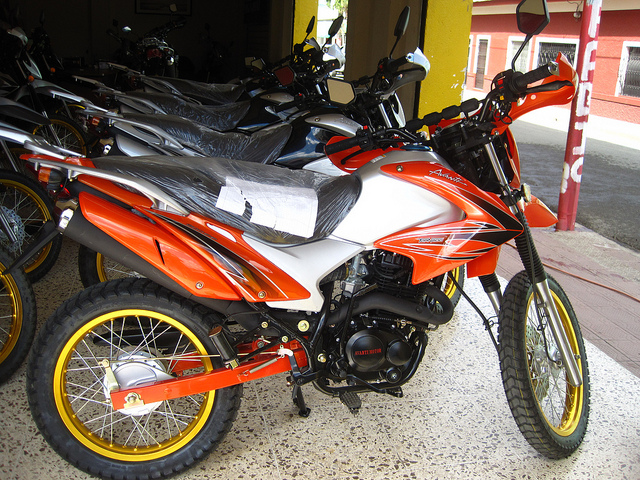Analyze the image in a comprehensive and detailed manner. The image prominently features an orange and white motorcycle displayed in the foreground. This motorcycle has distinct yellow accents on the rims and black tires suitable for off-road or adventure riding. The handlebars are well-defined, indicating it might be meant for comfortable handling. In the background, there are multiple other motorcycles, aligned in rows, some covered with protective plastic, suggesting they might be new or waiting to be purchased. The scene appears to be from a showroom or a dealership. Visible in the backdrop is an indoor setting with concrete flooring and pillars, indicating that these motorcycles are displayed indoors. 